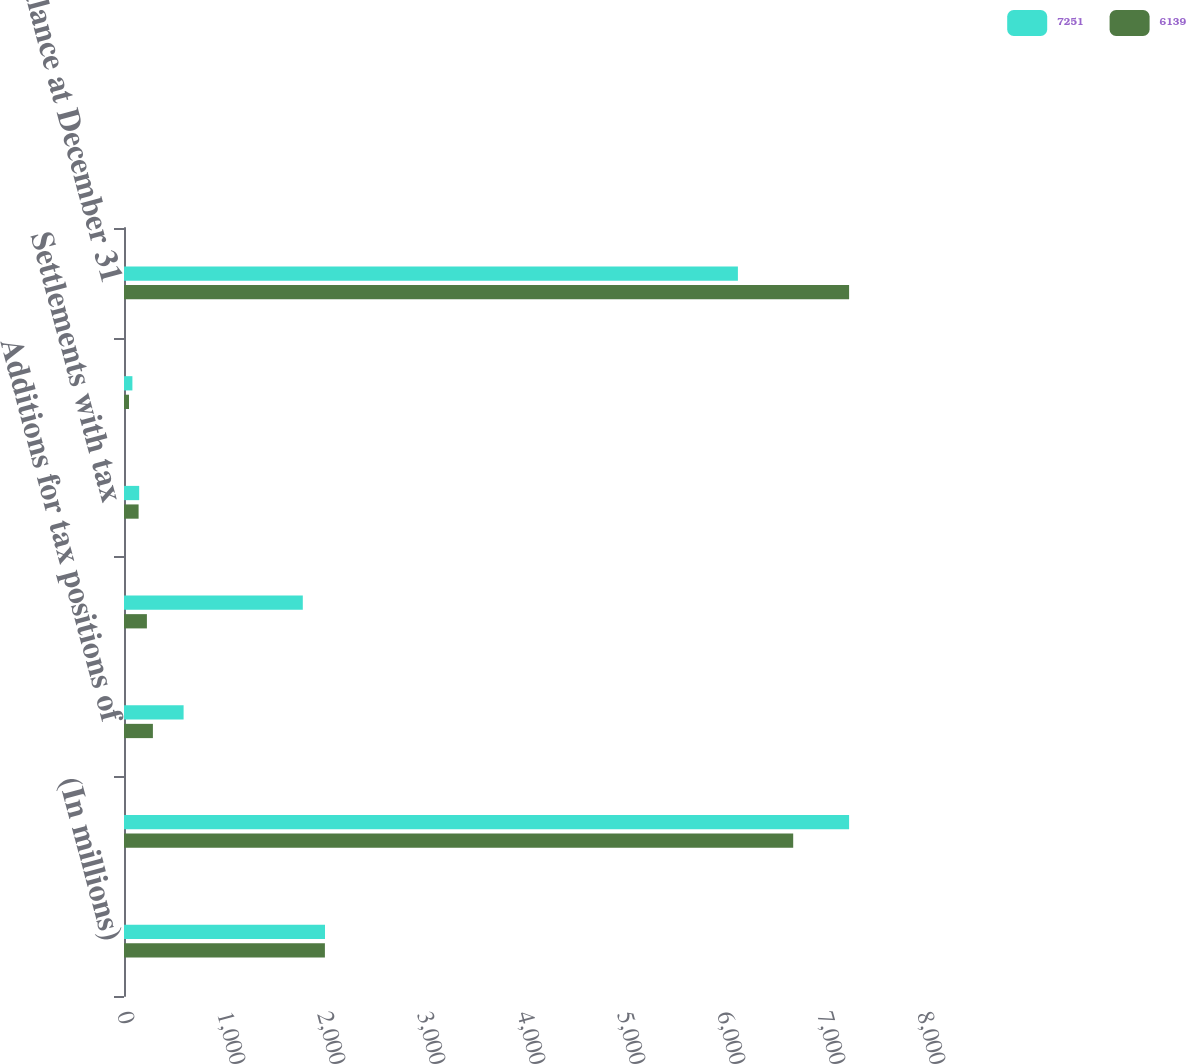Convert chart to OTSL. <chart><loc_0><loc_0><loc_500><loc_500><stacked_bar_chart><ecel><fcel>(In millions)<fcel>Balance at January 1<fcel>Additions for tax positions of<fcel>Reductions for tax positions<fcel>Settlements with tax<fcel>Expiration of the statute of<fcel>Balance at December 31<nl><fcel>7251<fcel>2010<fcel>7251<fcel>596<fcel>1788<fcel>152<fcel>84<fcel>6139<nl><fcel>6139<fcel>2009<fcel>6692<fcel>289<fcel>229<fcel>146<fcel>50<fcel>7251<nl></chart> 